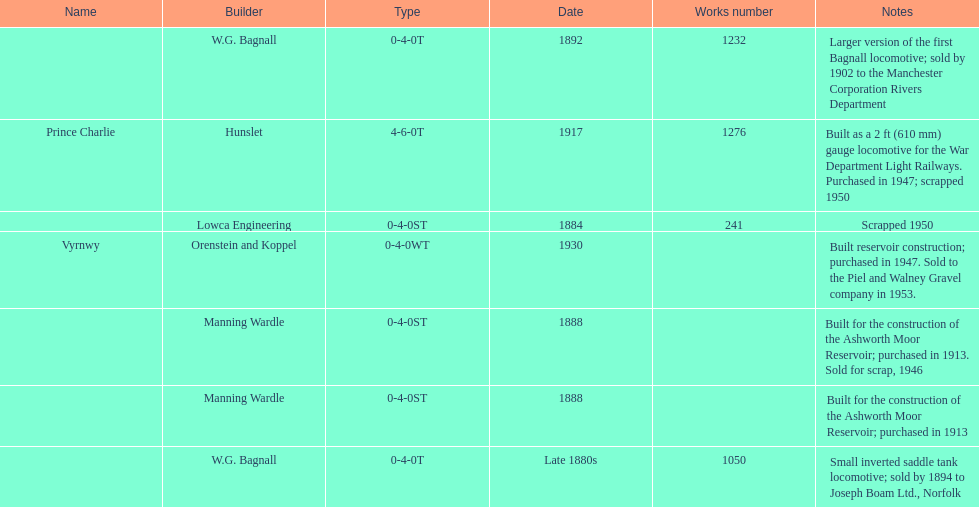How many locomotives were built after 1900? 2. 